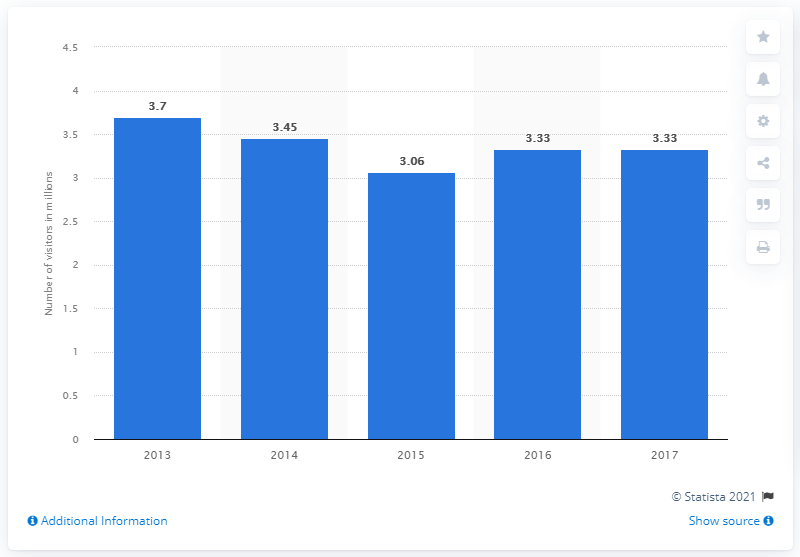List a handful of essential elements in this visual. In 2015, the Centre Pompidou in Paris received a total of 3,060,000 visitors. In 2017, the Centre Pompidou in Paris received a total of 3.33 million visitors. 